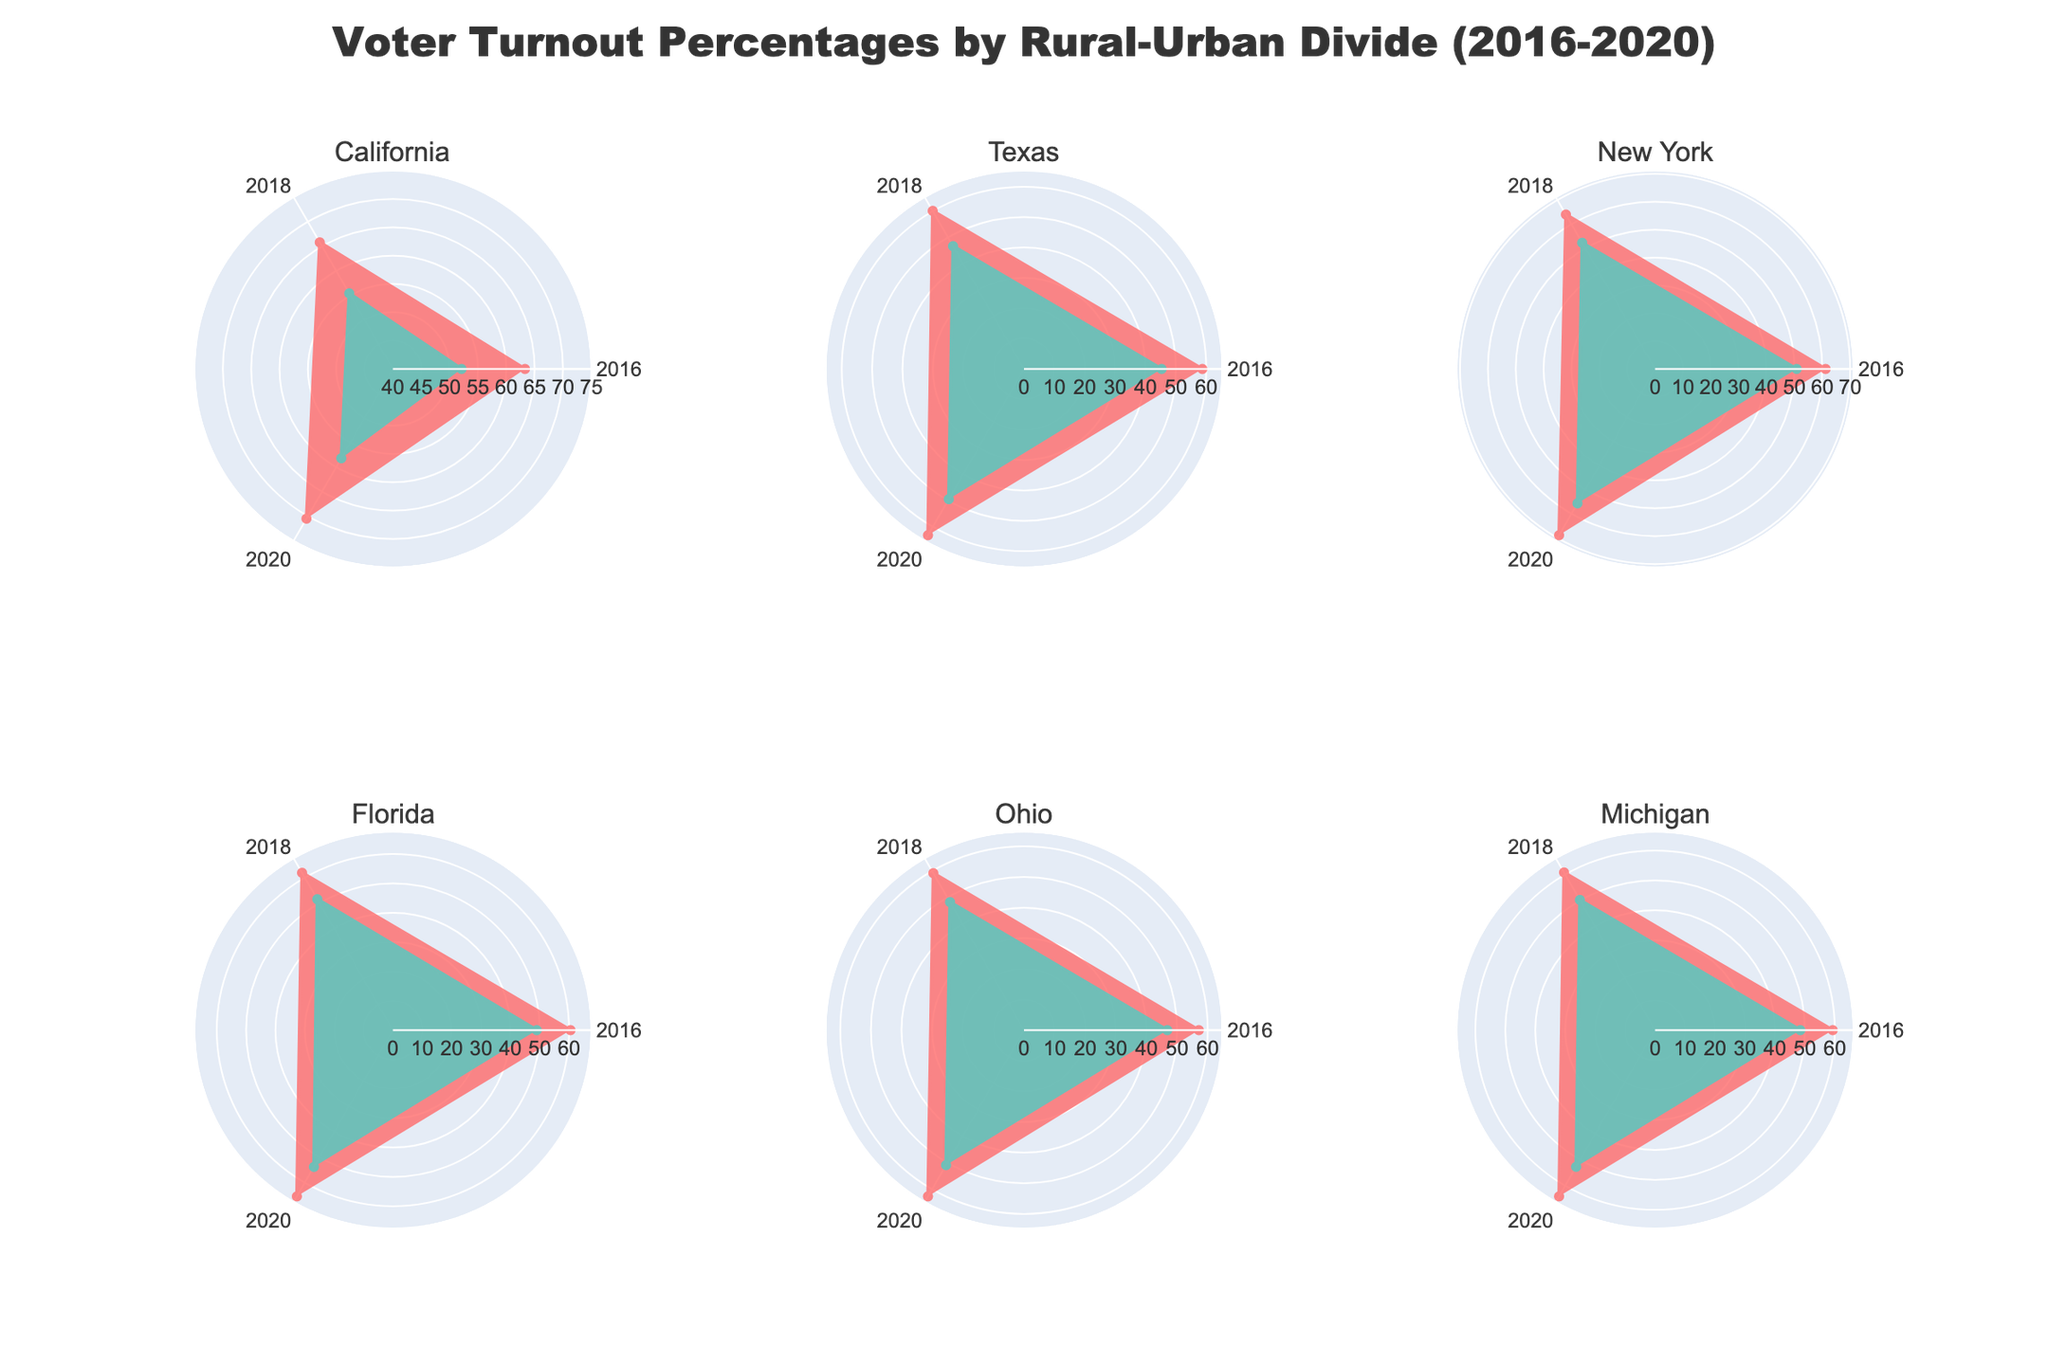Which state's urban voter turnout was highest in 2020? From the polar area chart, we look for the state with the highest radial value for urban regions in 2020. The highest turnout is in California with approximately 70.5%.
Answer: California How does rural voter turnout in Ohio compare to urban voter turnout in Michigan for the year 2018? Observe the radial distances for Ohio rural and Michigan urban in the 2018 section of the corresponding polar plots. Ohio rural voter turnout is slightly below 50, while Michigan urban is slightly above 60. This indicates Michigan's urban turnout is higher.
Answer: Michigan's urban turnout is higher What's the average voter turnout for rural areas across all listed states in 2016? Sum the 2016 rural voter turnout percentages for all states and divide by the number of states. 52.1 (CA) + 45.3 (TX) + 50.8 (NY) + 49.0 (FL) + 46.8 (OH) + 48.5 (MI) = 292.5. Then, 292.5 / 6 = 48.75.
Answer: 48.75 Is there a state where the rural turnout consistently lagged behind the urban turnout across all election cycles? Investigate each state's rural and urban turnout for 2016, 2018, and 2020. One such example is Texas, where rural turnout is consistently lower than urban turnout across all three years.
Answer: Yes, Texas Which region-state pair shows the most significant voter turnout improvement from 2016 to 2020? Identify the region-state pair with the largest increase in the radial value from 2016 to 2020. For urban areas, it is California with an increase from around 63.3% to 70.5%, a change of 7.2%.
Answer: California (urban) How did Florida’s urban turnout in 2018 compare to California's rural turnout in 2020? Compare the radial distances for Florida urban in 2018 and California rural in 2020. Florida's urban turnout in 2018 is about 61.9%, which is higher than California's rural turnout in 2020, which is 58.2%.
Answer: Florida’s urban turnout is higher What can be inferred about the overall trend in voter turnout from 2016 to 2020 for both rural and urban regions? Examine the direction and length of the radial plots from 2016 to 2020. In all states and both regions, turnout increases are observed, pointing to an overall upward trend in voter turnout.
Answer: Increasing trend 